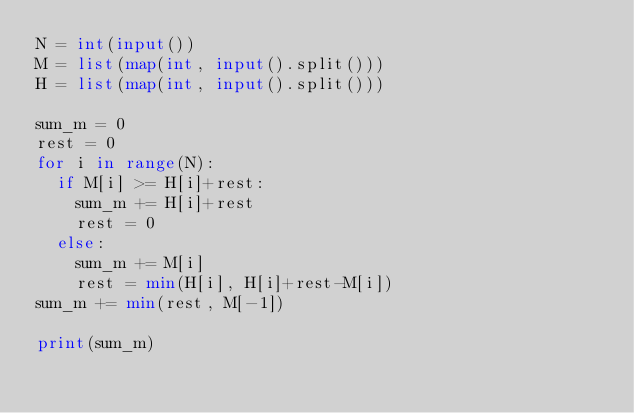Convert code to text. <code><loc_0><loc_0><loc_500><loc_500><_Python_>N = int(input())
M = list(map(int, input().split()))
H = list(map(int, input().split()))

sum_m = 0
rest = 0
for i in range(N):
  if M[i] >= H[i]+rest:
    sum_m += H[i]+rest
    rest = 0
  else:
    sum_m += M[i]
    rest = min(H[i], H[i]+rest-M[i])
sum_m += min(rest, M[-1])

print(sum_m)
</code> 